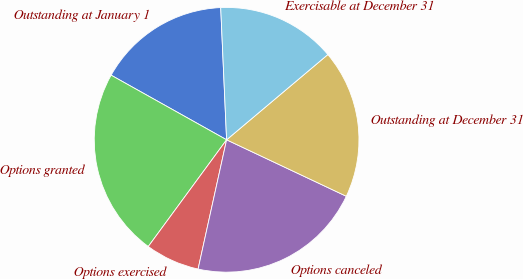<chart> <loc_0><loc_0><loc_500><loc_500><pie_chart><fcel>Outstanding at January 1<fcel>Options granted<fcel>Options exercised<fcel>Options canceled<fcel>Outstanding at December 31<fcel>Exercisable at December 31<nl><fcel>16.17%<fcel>23.04%<fcel>6.62%<fcel>21.44%<fcel>18.15%<fcel>14.57%<nl></chart> 